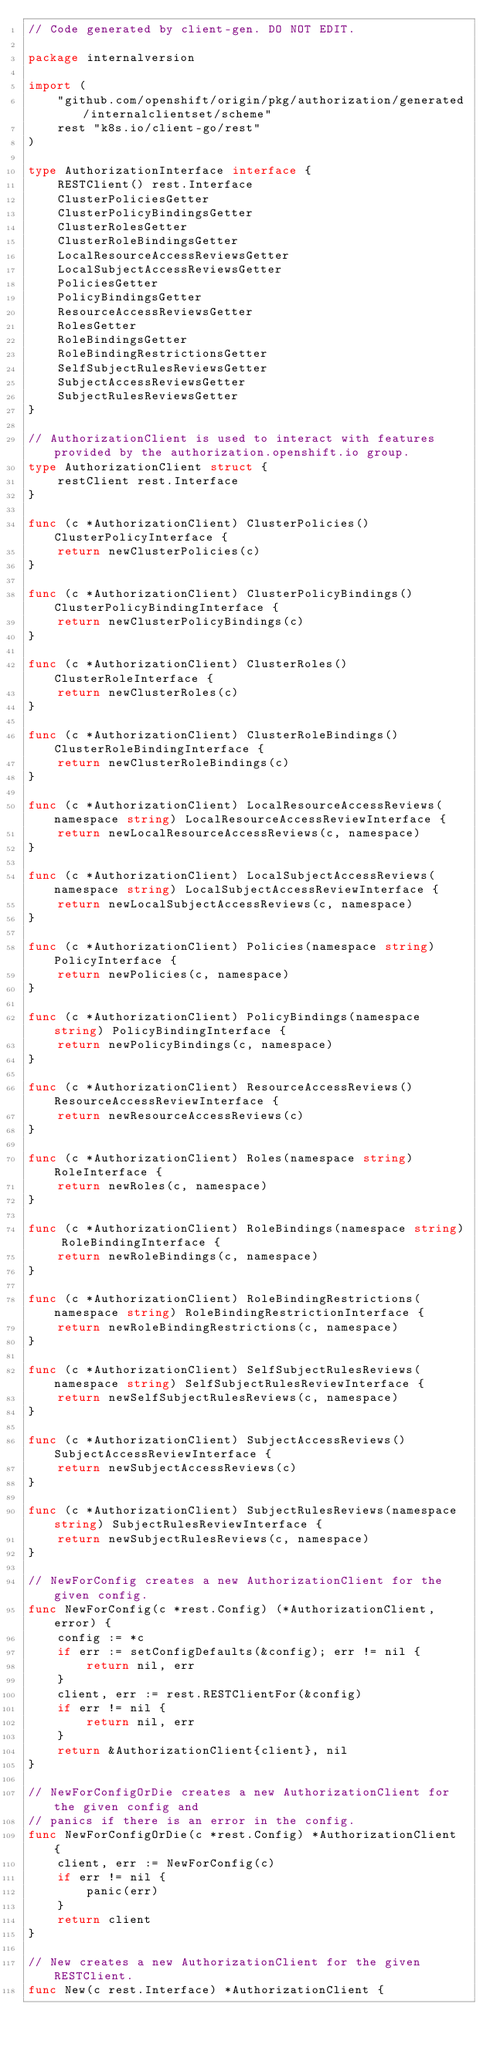Convert code to text. <code><loc_0><loc_0><loc_500><loc_500><_Go_>// Code generated by client-gen. DO NOT EDIT.

package internalversion

import (
	"github.com/openshift/origin/pkg/authorization/generated/internalclientset/scheme"
	rest "k8s.io/client-go/rest"
)

type AuthorizationInterface interface {
	RESTClient() rest.Interface
	ClusterPoliciesGetter
	ClusterPolicyBindingsGetter
	ClusterRolesGetter
	ClusterRoleBindingsGetter
	LocalResourceAccessReviewsGetter
	LocalSubjectAccessReviewsGetter
	PoliciesGetter
	PolicyBindingsGetter
	ResourceAccessReviewsGetter
	RolesGetter
	RoleBindingsGetter
	RoleBindingRestrictionsGetter
	SelfSubjectRulesReviewsGetter
	SubjectAccessReviewsGetter
	SubjectRulesReviewsGetter
}

// AuthorizationClient is used to interact with features provided by the authorization.openshift.io group.
type AuthorizationClient struct {
	restClient rest.Interface
}

func (c *AuthorizationClient) ClusterPolicies() ClusterPolicyInterface {
	return newClusterPolicies(c)
}

func (c *AuthorizationClient) ClusterPolicyBindings() ClusterPolicyBindingInterface {
	return newClusterPolicyBindings(c)
}

func (c *AuthorizationClient) ClusterRoles() ClusterRoleInterface {
	return newClusterRoles(c)
}

func (c *AuthorizationClient) ClusterRoleBindings() ClusterRoleBindingInterface {
	return newClusterRoleBindings(c)
}

func (c *AuthorizationClient) LocalResourceAccessReviews(namespace string) LocalResourceAccessReviewInterface {
	return newLocalResourceAccessReviews(c, namespace)
}

func (c *AuthorizationClient) LocalSubjectAccessReviews(namespace string) LocalSubjectAccessReviewInterface {
	return newLocalSubjectAccessReviews(c, namespace)
}

func (c *AuthorizationClient) Policies(namespace string) PolicyInterface {
	return newPolicies(c, namespace)
}

func (c *AuthorizationClient) PolicyBindings(namespace string) PolicyBindingInterface {
	return newPolicyBindings(c, namespace)
}

func (c *AuthorizationClient) ResourceAccessReviews() ResourceAccessReviewInterface {
	return newResourceAccessReviews(c)
}

func (c *AuthorizationClient) Roles(namespace string) RoleInterface {
	return newRoles(c, namespace)
}

func (c *AuthorizationClient) RoleBindings(namespace string) RoleBindingInterface {
	return newRoleBindings(c, namespace)
}

func (c *AuthorizationClient) RoleBindingRestrictions(namespace string) RoleBindingRestrictionInterface {
	return newRoleBindingRestrictions(c, namespace)
}

func (c *AuthorizationClient) SelfSubjectRulesReviews(namespace string) SelfSubjectRulesReviewInterface {
	return newSelfSubjectRulesReviews(c, namespace)
}

func (c *AuthorizationClient) SubjectAccessReviews() SubjectAccessReviewInterface {
	return newSubjectAccessReviews(c)
}

func (c *AuthorizationClient) SubjectRulesReviews(namespace string) SubjectRulesReviewInterface {
	return newSubjectRulesReviews(c, namespace)
}

// NewForConfig creates a new AuthorizationClient for the given config.
func NewForConfig(c *rest.Config) (*AuthorizationClient, error) {
	config := *c
	if err := setConfigDefaults(&config); err != nil {
		return nil, err
	}
	client, err := rest.RESTClientFor(&config)
	if err != nil {
		return nil, err
	}
	return &AuthorizationClient{client}, nil
}

// NewForConfigOrDie creates a new AuthorizationClient for the given config and
// panics if there is an error in the config.
func NewForConfigOrDie(c *rest.Config) *AuthorizationClient {
	client, err := NewForConfig(c)
	if err != nil {
		panic(err)
	}
	return client
}

// New creates a new AuthorizationClient for the given RESTClient.
func New(c rest.Interface) *AuthorizationClient {</code> 